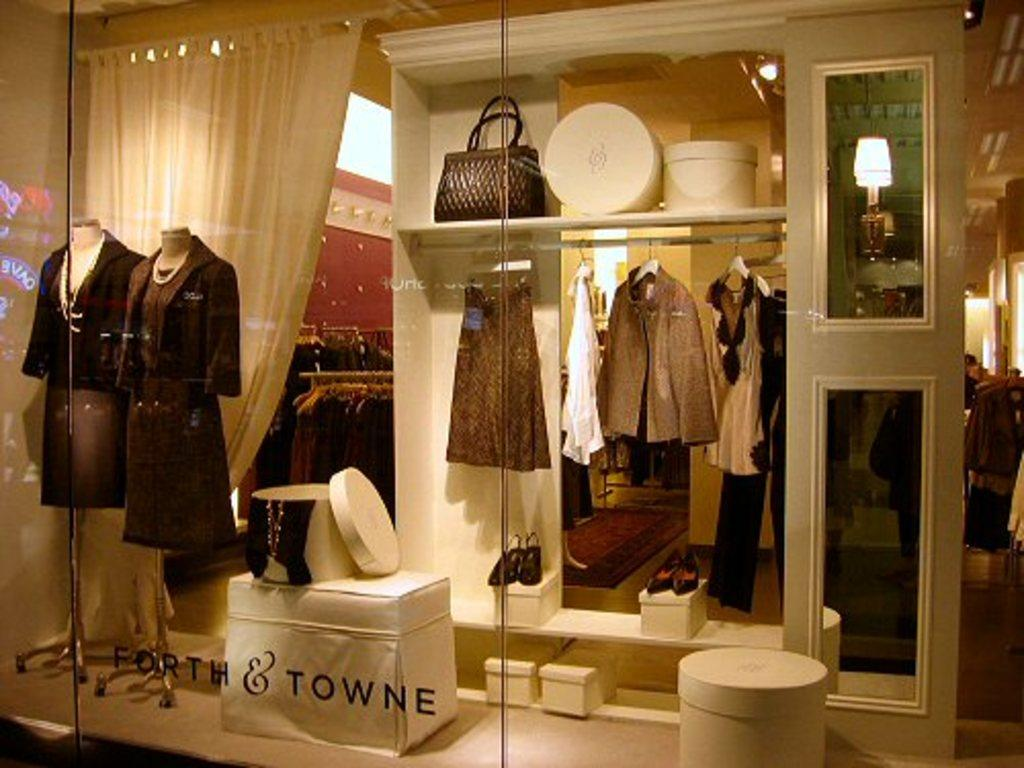Provide a one-sentence caption for the provided image. Ladies clothing shop window featuring dresses and the name Forth & Towne. 